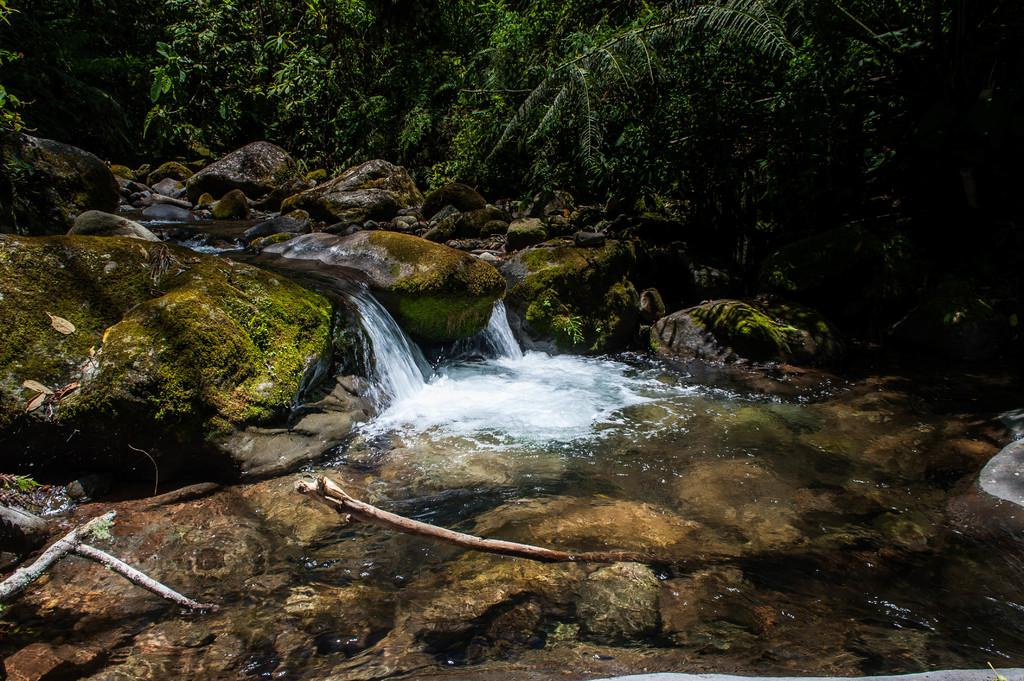Where was the image taken? The image was clicked outside. What natural feature can be seen in the image? There is a waterfall in the image. What is located at the bottom of the image? Rocks are present at the bottom of the image. What type of vegetation is visible in the background of the image? There are trees in the background of the image. Which side of the image has water flowing? Water is flowing on the right side of the image. What type of soup is being served in the image? There is no soup present in the image; it features a waterfall and surrounding natural elements. What kind of glue is used to hold the rocks together in the image? There is no glue present in the image; the rocks are naturally situated at the bottom of the waterfall. 